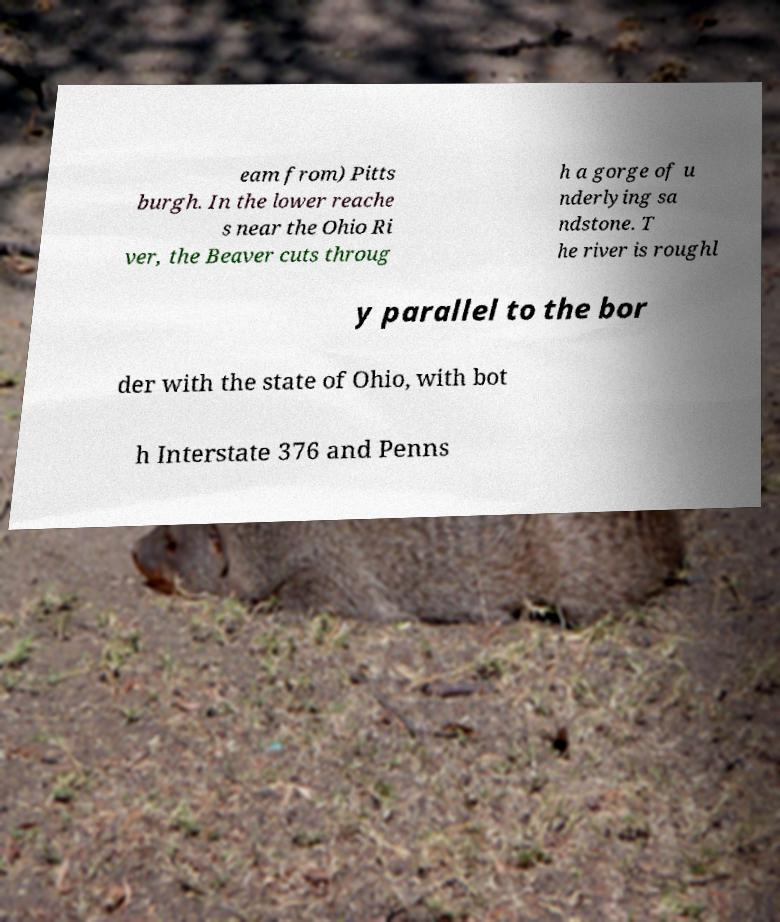Can you accurately transcribe the text from the provided image for me? eam from) Pitts burgh. In the lower reache s near the Ohio Ri ver, the Beaver cuts throug h a gorge of u nderlying sa ndstone. T he river is roughl y parallel to the bor der with the state of Ohio, with bot h Interstate 376 and Penns 